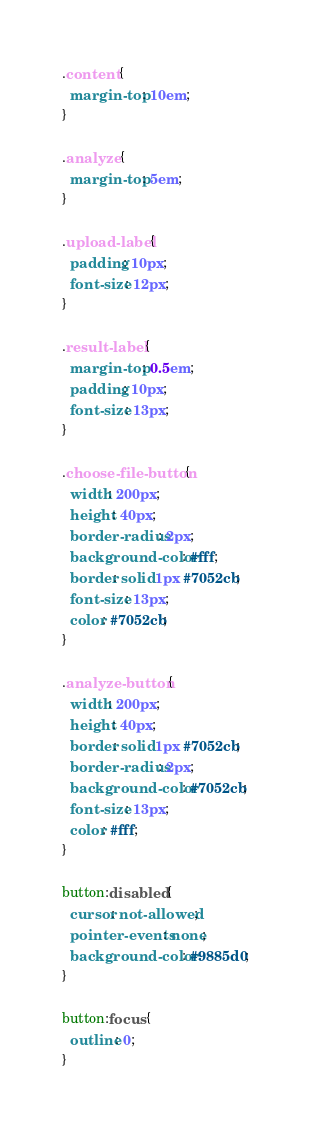<code> <loc_0><loc_0><loc_500><loc_500><_CSS_>.content {
  margin-top: 10em;
}

.analyze {
  margin-top: 5em;
}

.upload-label {
  padding: 10px;
  font-size: 12px;
}

.result-label {
  margin-top: 0.5em;
  padding: 10px;
  font-size: 13px;
}

.choose-file-button {
  width: 200px;
  height: 40px;
  border-radius: 2px;
  background-color: #fff;
  border: solid 1px #7052cb;
  font-size: 13px;
  color: #7052cb;
}

.analyze-button {
  width: 200px;
  height: 40px;
  border: solid 1px #7052cb;
  border-radius: 2px;
  background-color: #7052cb;
  font-size: 13px;
  color: #fff;
}

button:disabled {
  cursor: not-allowed;
  pointer-events: none;
  background-color: #9885d0;
}

button:focus {
  outline: 0;
}
</code> 